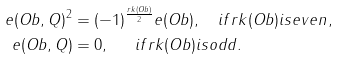Convert formula to latex. <formula><loc_0><loc_0><loc_500><loc_500>e ( O b , Q ) ^ { 2 } & = ( - 1 ) ^ { \frac { r k ( O b ) } { 2 } } e ( O b ) , \quad i f r k ( O b ) i s e v e n , \\ e ( O b , Q ) & = 0 , \quad \ \, i f r k ( O b ) i s o d d .</formula> 